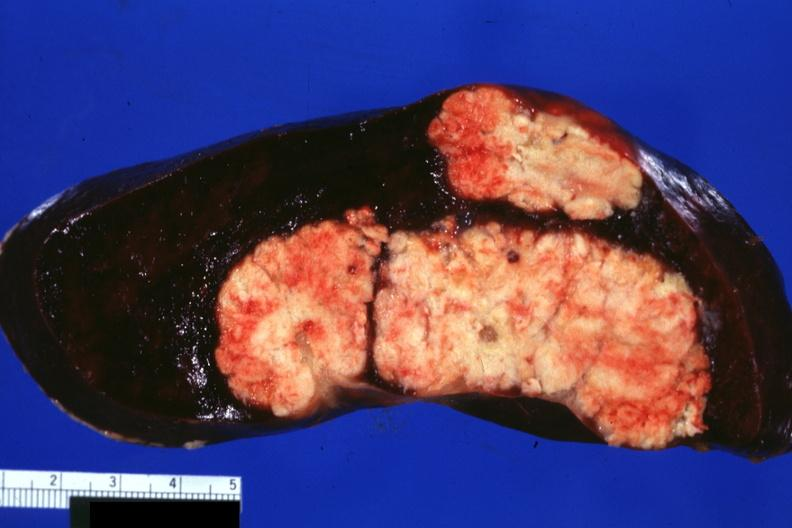s metastatic colon cancer present?
Answer the question using a single word or phrase. Yes 